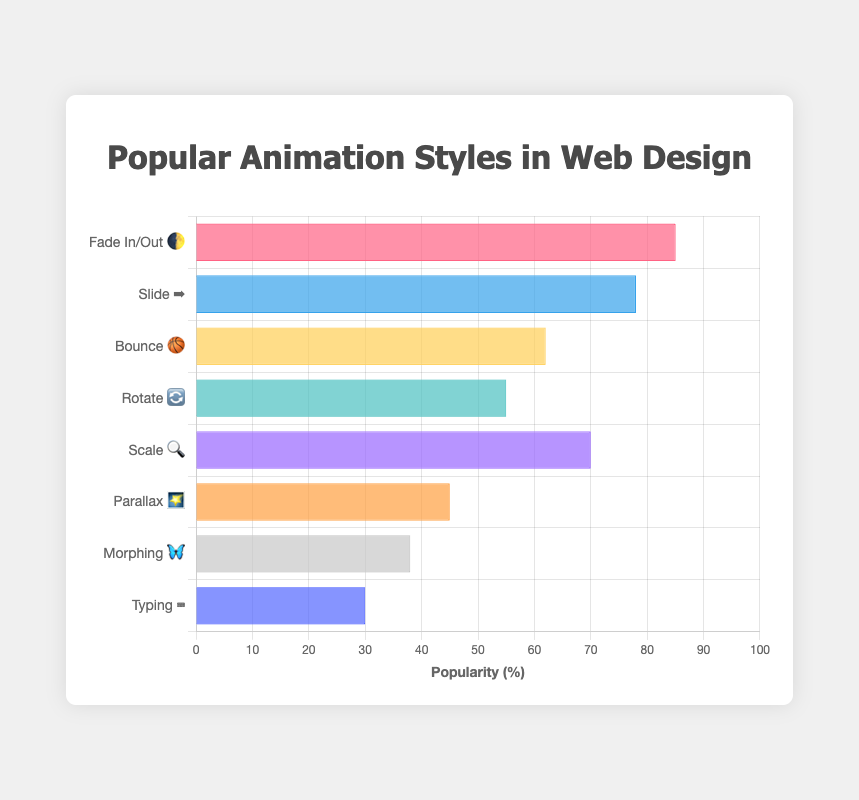What is the most popular animation style? The bar labeled "Fade In/Out 🌓" has the highest value on the x-axis, which represents popularity.
Answer: Fade In/Out 🌓 Which animation style has the least popularity? The bar labeled "Typing ⌨️" has the lowest value on the x-axis.
Answer: Typing ⌨️ How many animation styles have a popularity greater than 60%? Checking each bar label and its respective popularity value, the bars for "Fade In/Out 🌓," "Slide ➡️," "Scale 🔍," and "Bounce 🏀" have values greater than 60.
Answer: 4 Which animation style is more popular, "Parallax 🌠" or "Morphing 🦋"? The bar labeled "Parallax 🌠" has a popularity of 45, and the bar labeled "Morphing 🦋" has a popularity of 38. Since 45 > 38, "Parallax 🌠" is more popular.
Answer: Parallax 🌠 What is the average popularity of the "Rotate 🔄" and "Scale 🔍" styles? The popularity values for "Rotate 🔄" and "Scale 🔍" are 55 and 70 respectively. The average is (55 + 70) / 2.
Answer: 62.5 Which animation style has exactly 70% popularity? The bar labeled "Scale 🔍" has a popularity of 70.
Answer: Scale 🔍 How much more popular is "Fade In/Out 🌓" than "Bounce 🏀"? The popularity of "Fade In/Out 🌓" is 85 and "Bounce 🏀" is 62. The difference is 85 - 62.
Answer: 23 What is the total popularity of all animation styles combined? Add all the popularity values: 85 + 78 + 62 + 55 + 70 + 45 + 38 + 30.
Answer: 463 What is the middle value of the popularity among these animation styles (the median)? First, arrange the popularity values in order: 30, 38, 45, 55, 62, 70, 78, 85. The median is the average of the 4th and 5th values, which are 55 and 62. The median is (55 + 62) / 2.
Answer: 58.5 Which animation styles have a popularity between 50% and 80%? The animation styles within this range are "Slide ➡️" (78), "Bounce 🏀" (62), "Rotate 🔄" (55), and "Scale 🔍" (70).
Answer: Slide ➡️, Bounce 🏀, Rotate 🔄, Scale 🔍 